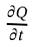Convert formula to latex. <formula><loc_0><loc_0><loc_500><loc_500>\frac { \partial Q } { \partial t }</formula> 